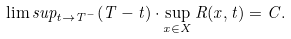<formula> <loc_0><loc_0><loc_500><loc_500>\lim s u p _ { t \rightarrow T ^ { - } } ( T - t ) \cdot \sup _ { x \in X } R ( x , t ) = C .</formula> 